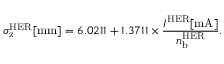Convert formula to latex. <formula><loc_0><loc_0><loc_500><loc_500>\sigma _ { z } ^ { H E R } [ m m ] = 6 . 0 2 1 1 + 1 . 3 7 1 1 \times \frac { I ^ { H E R } [ m A ] } { n _ { b } ^ { H E R } } .</formula> 